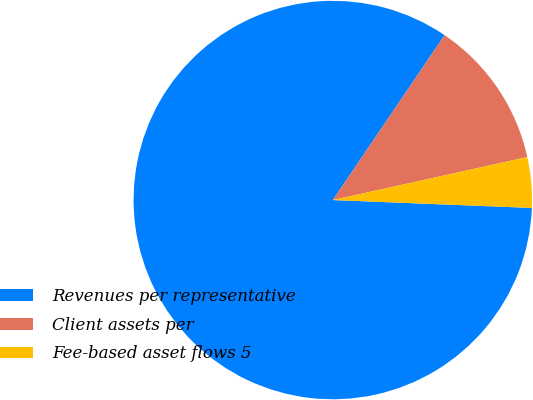Convert chart to OTSL. <chart><loc_0><loc_0><loc_500><loc_500><pie_chart><fcel>Revenues per representative<fcel>Client assets per<fcel>Fee-based asset flows 5<nl><fcel>83.85%<fcel>12.06%<fcel>4.09%<nl></chart> 